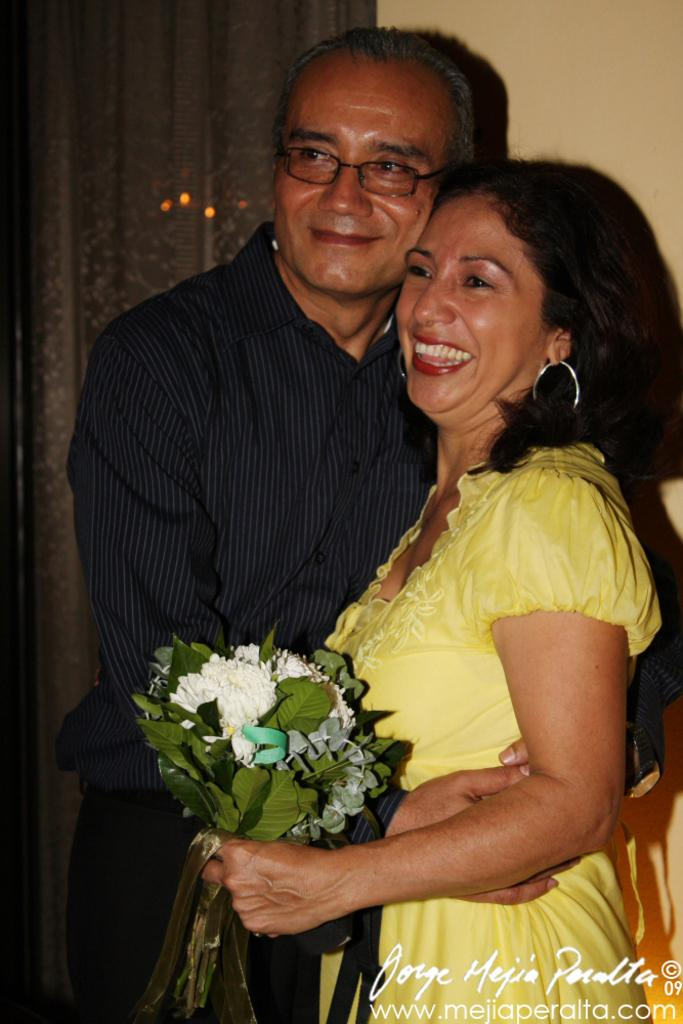What is the woman in the image holding? The woman is holding a bouquet. What is the woman wearing in the image? The woman is wearing a yellow dress. Who is beside the woman in the image? There is a person beside the woman in the image. What can be seen in the background of the image? There is a wall in the background of the image. Where is the text located in the image? The text is in the right bottom of the image. What type of nerve can be seen in the image? There is no nerve present in the image. How does the flock of birds fly in the image? There are no birds or flock in the image. 